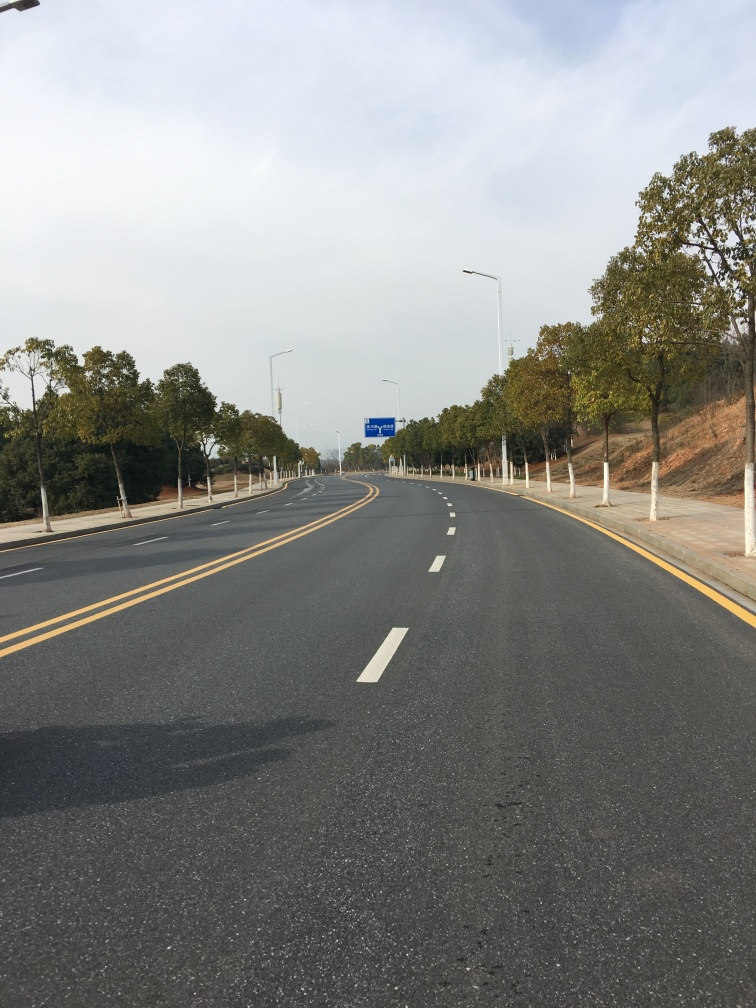Can you tell something about the location or environment? The environment seems to be a semi-rural or suburban area, given the presence of well-maintained roadside trees and the lack of urban infrastructure like tall buildings or signs of city life. The road seems to be leading towards a destination that may be just out of the frame. 